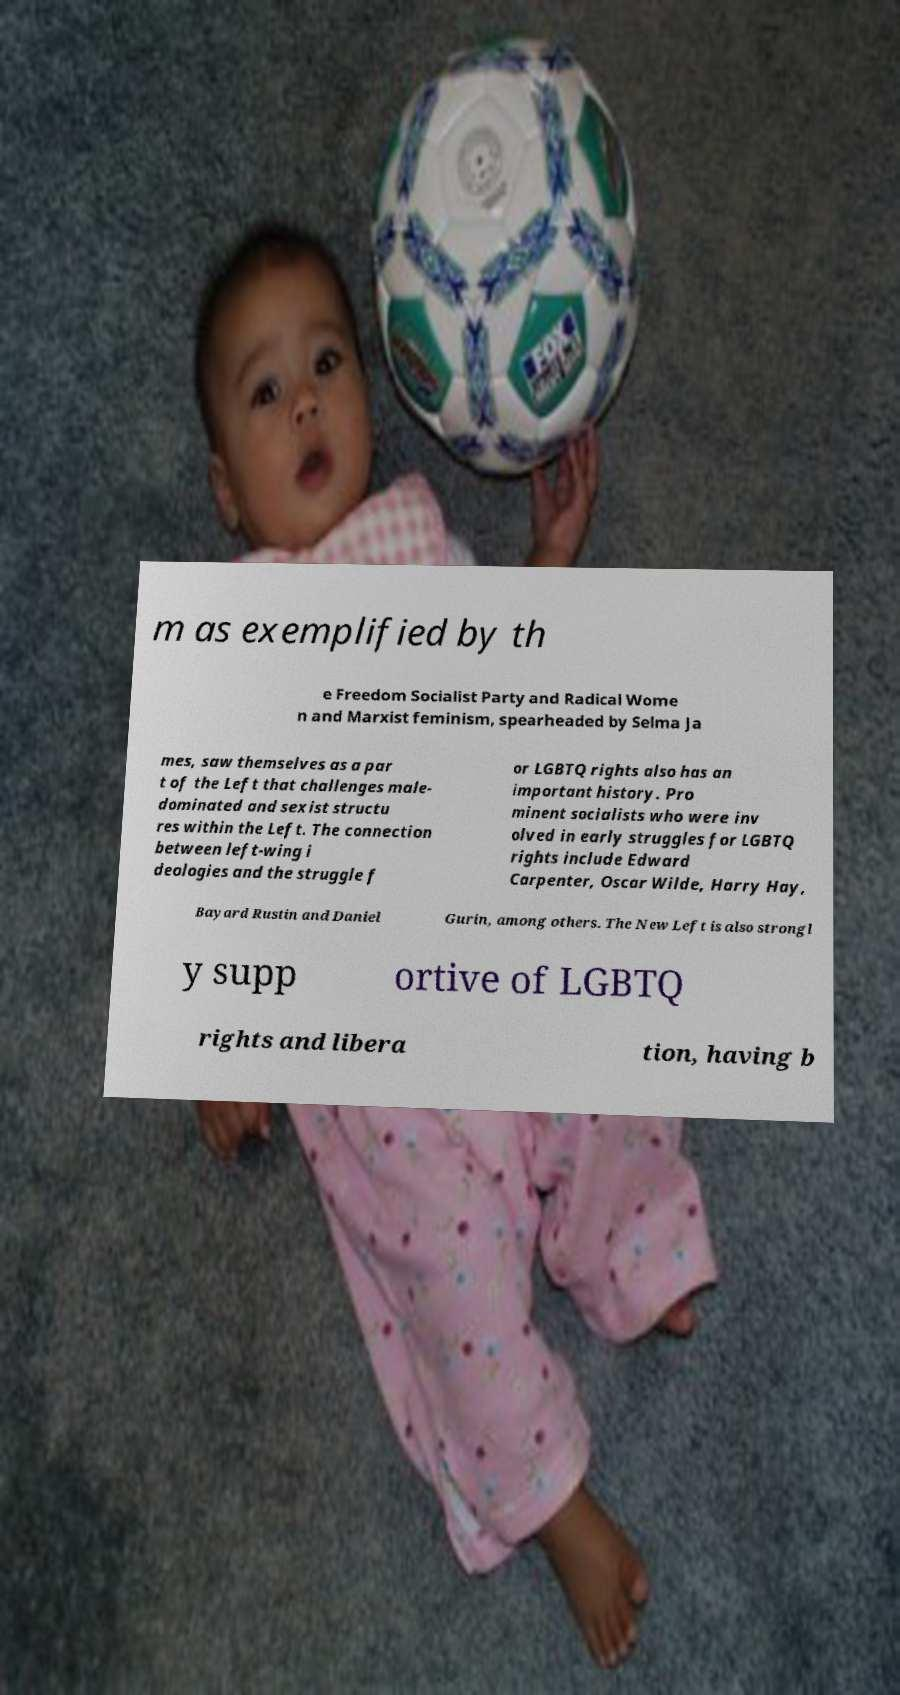Could you assist in decoding the text presented in this image and type it out clearly? m as exemplified by th e Freedom Socialist Party and Radical Wome n and Marxist feminism, spearheaded by Selma Ja mes, saw themselves as a par t of the Left that challenges male- dominated and sexist structu res within the Left. The connection between left-wing i deologies and the struggle f or LGBTQ rights also has an important history. Pro minent socialists who were inv olved in early struggles for LGBTQ rights include Edward Carpenter, Oscar Wilde, Harry Hay, Bayard Rustin and Daniel Gurin, among others. The New Left is also strongl y supp ortive of LGBTQ rights and libera tion, having b 